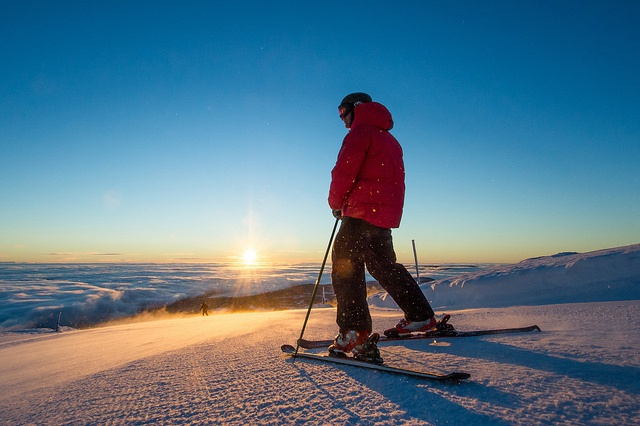Describe the objects in this image and their specific colors. I can see people in blue, maroon, black, gray, and brown tones, skis in blue, black, gray, and navy tones, and people in blue, maroon, brown, and orange tones in this image. 